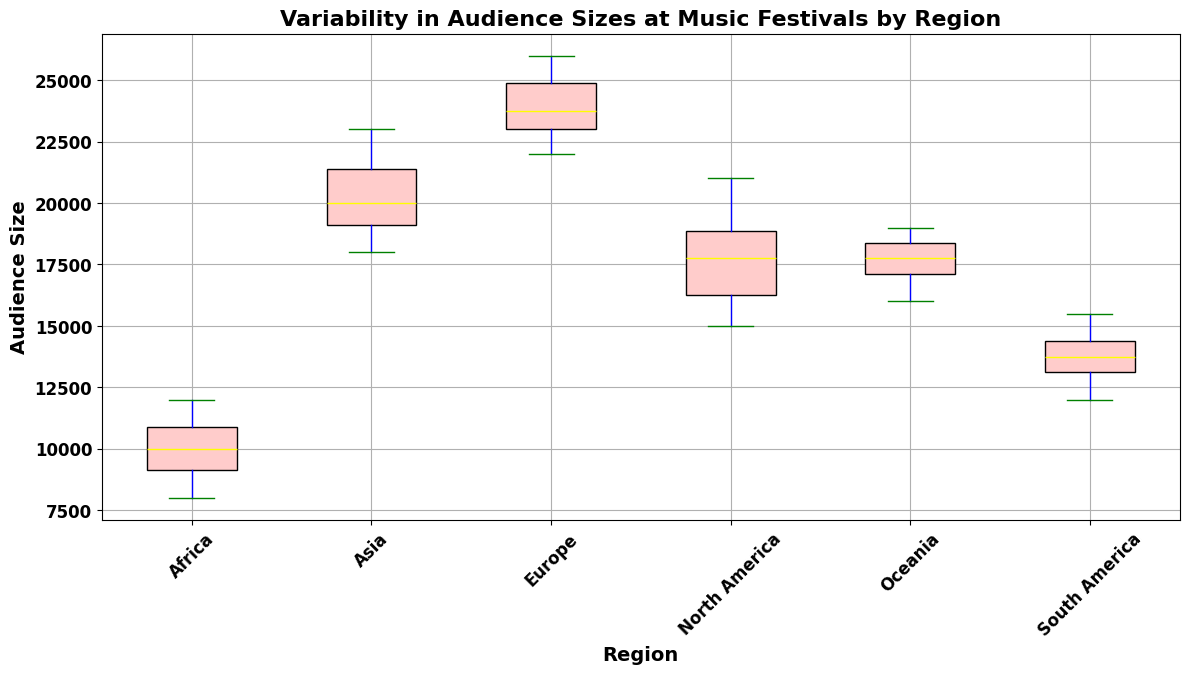What region has the highest median audience size? The box plot's median line is the yellow line within each box. The region with the highest median line represents the highest median audience size.
Answer: Europe Which region has the largest interquartile range (IQR) in audience size? The interquartile range (IQR) is represented by the length of the box from the first quartile (Q1) to the third quartile (Q3). The region with the tallest box has the largest IQR.
Answer: Europe Is the median audience size in North America greater than that in Asia? Compare the yellow median lines in the boxes for North America and Asia. The median line for North America appears to be at 17500, while Asia's median is at 20000.
Answer: No Which region has the smallest range of audience sizes? The range is represented by the full span from the lower whisker to the upper whisker. The region with the shortest distance between these points has the smallest range.
Answer: South America How does the variability in audience sizes for Africa compare to that of Oceania? Compare the length of the boxes and their whiskers. Africa's box and whiskers are shorter compared to those of Oceania's, indicating less variability.
Answer: Less variability What is the approximate median audience size for South America? Look at the yellow line inside the South America box. It appears to be around 14000.
Answer: 14000 Are there any outliers in the audience sizes for North America? Outliers are depicted as red circles outside the whiskers. For North America, there are no red circles visible outside the whiskers.
Answer: No Which region has the highest upper whisker, indicating the maximum audience size? The upper whisker is the top line extending from the box. The region with the highest upper whisker represents the highest maximum audience size.
Answer: Europe What can be said about the spread of audience sizes in Asia as compared to Africa? Compare the length of the boxes and whiskers. Asia has a taller box and longer whiskers than Africa, indicating a higher spread in audience sizes.
Answer: Higher spread in Asia 